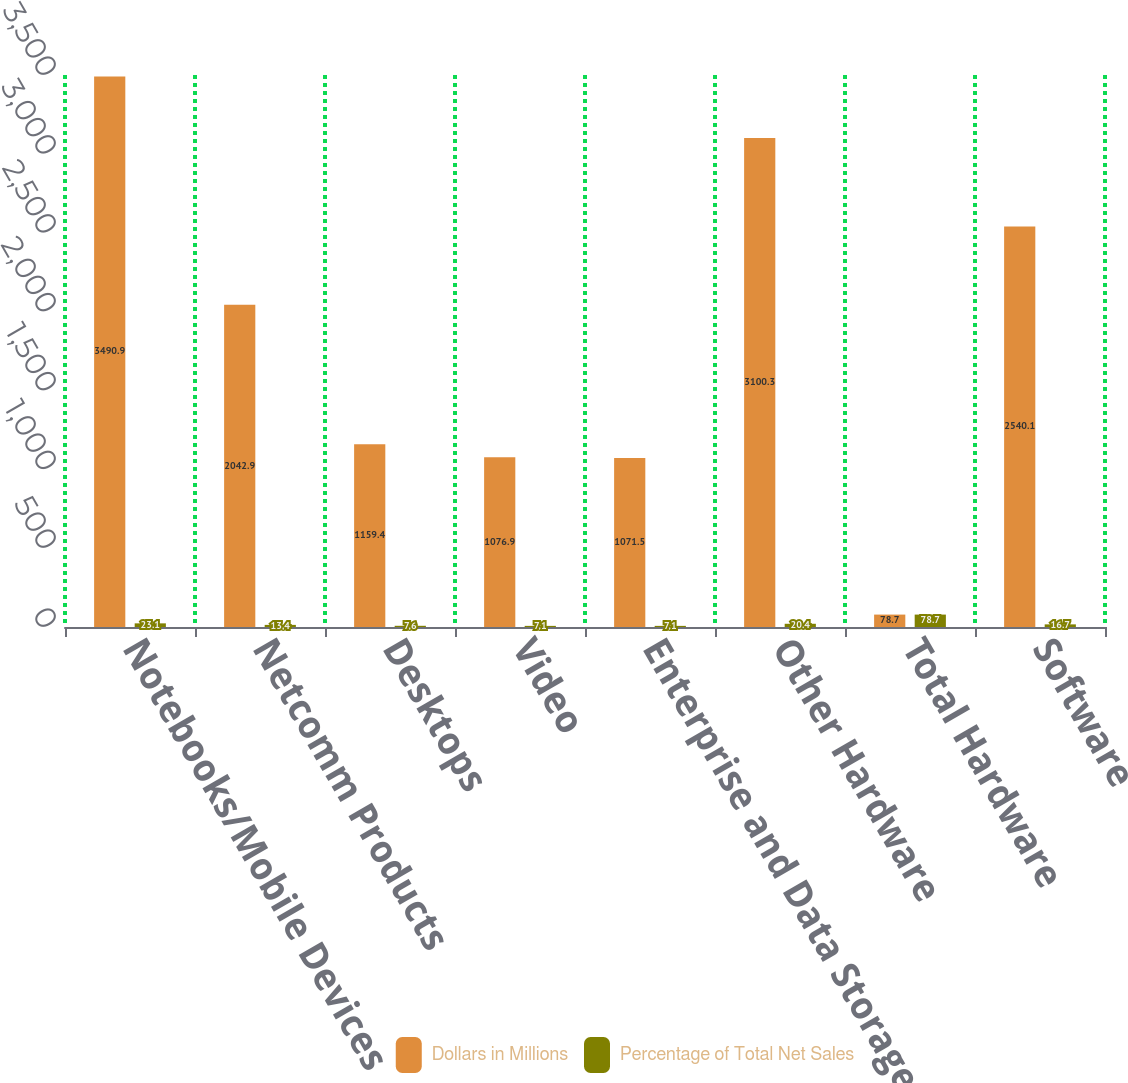Convert chart. <chart><loc_0><loc_0><loc_500><loc_500><stacked_bar_chart><ecel><fcel>Notebooks/Mobile Devices<fcel>Netcomm Products<fcel>Desktops<fcel>Video<fcel>Enterprise and Data Storage<fcel>Other Hardware<fcel>Total Hardware<fcel>Software<nl><fcel>Dollars in Millions<fcel>3490.9<fcel>2042.9<fcel>1159.4<fcel>1076.9<fcel>1071.5<fcel>3100.3<fcel>78.7<fcel>2540.1<nl><fcel>Percentage of Total Net Sales<fcel>23.1<fcel>13.4<fcel>7.6<fcel>7.1<fcel>7.1<fcel>20.4<fcel>78.7<fcel>16.7<nl></chart> 